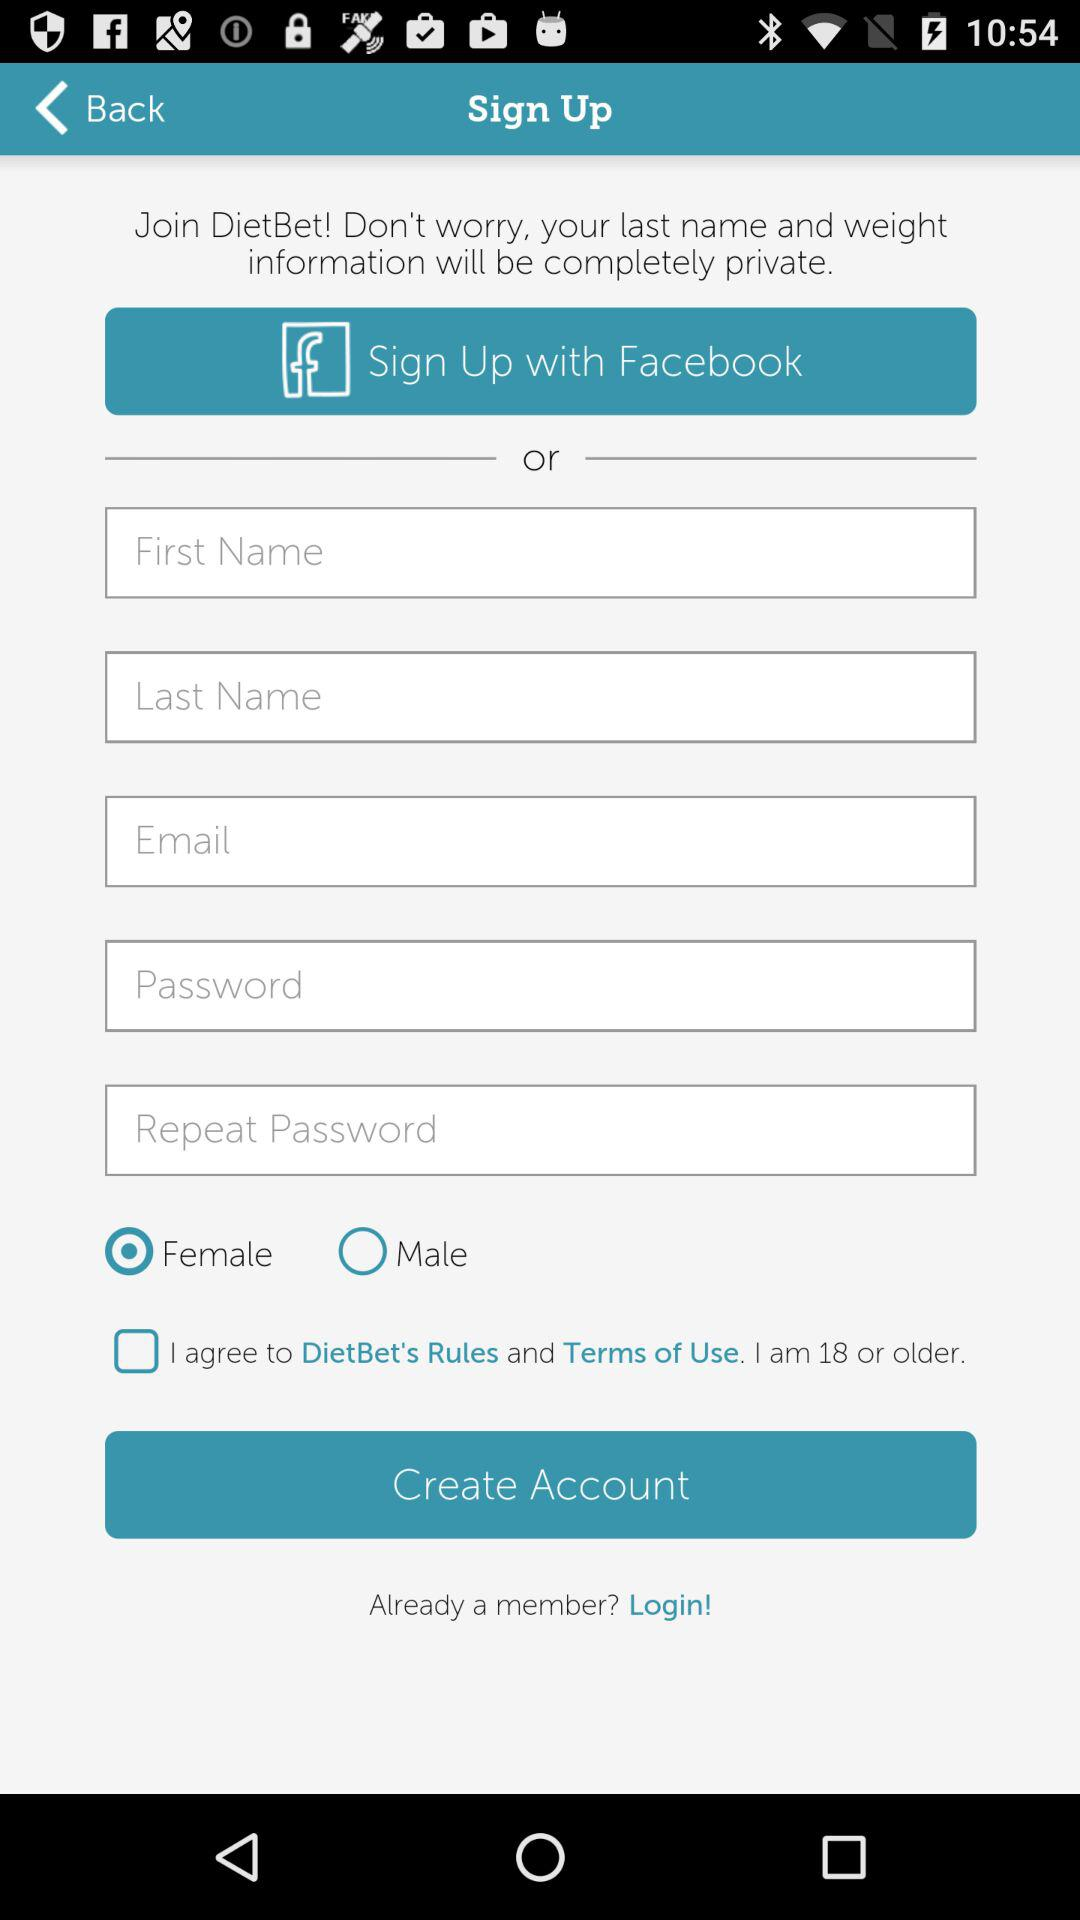What application can the sign-up be done with? The application with which the sign-up can be done is "Facebook". 